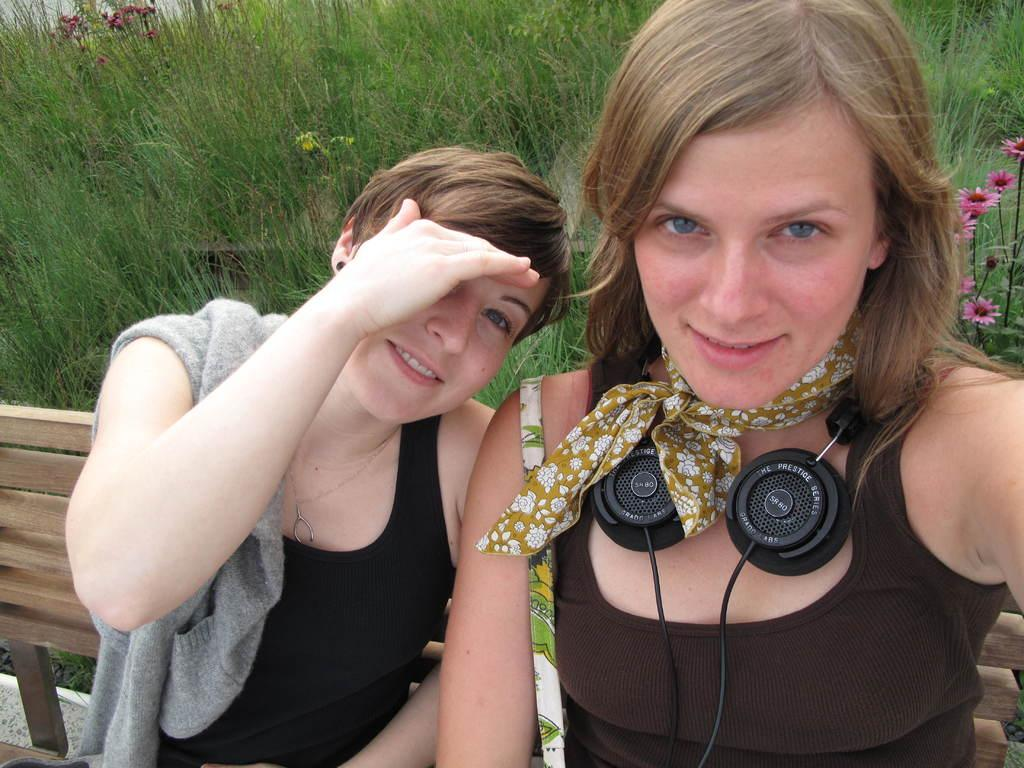How many people are in the image? There are two women in the image. What are the women doing in the image? The women are sitting on a bench and taking a selfie. What type of surface are the women sitting on? There is grass visible in the image, which suggests they are sitting on a grassy surface. Are there any plants visible in the image? Yes, there are flowers in the image. What type of mint is growing on the women's thumbs in the image? There is no mint or any reference to thumbs, or mint growing on thumbs in the image. 